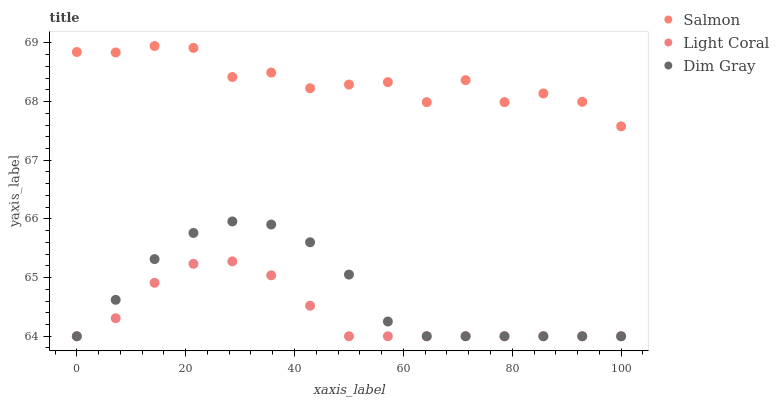Does Light Coral have the minimum area under the curve?
Answer yes or no. Yes. Does Salmon have the maximum area under the curve?
Answer yes or no. Yes. Does Dim Gray have the minimum area under the curve?
Answer yes or no. No. Does Dim Gray have the maximum area under the curve?
Answer yes or no. No. Is Light Coral the smoothest?
Answer yes or no. Yes. Is Salmon the roughest?
Answer yes or no. Yes. Is Dim Gray the smoothest?
Answer yes or no. No. Is Dim Gray the roughest?
Answer yes or no. No. Does Light Coral have the lowest value?
Answer yes or no. Yes. Does Salmon have the lowest value?
Answer yes or no. No. Does Salmon have the highest value?
Answer yes or no. Yes. Does Dim Gray have the highest value?
Answer yes or no. No. Is Dim Gray less than Salmon?
Answer yes or no. Yes. Is Salmon greater than Dim Gray?
Answer yes or no. Yes. Does Dim Gray intersect Light Coral?
Answer yes or no. Yes. Is Dim Gray less than Light Coral?
Answer yes or no. No. Is Dim Gray greater than Light Coral?
Answer yes or no. No. Does Dim Gray intersect Salmon?
Answer yes or no. No. 